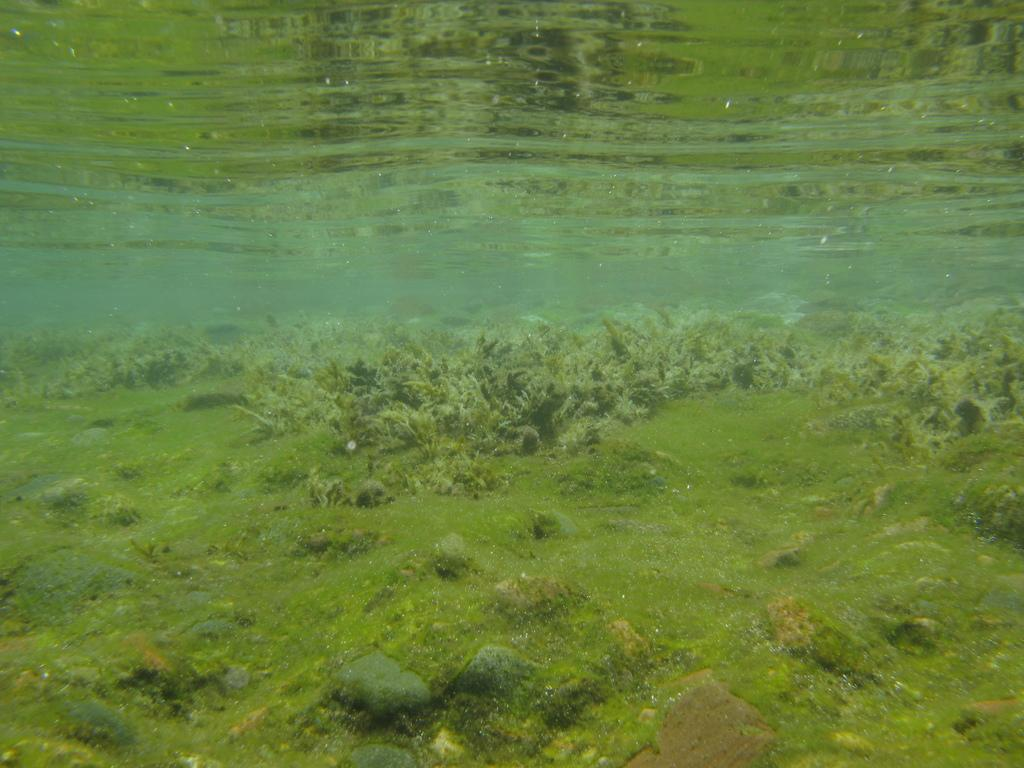What type of natural feature is present in the image? There is a lake in the image. What can be found within the lake in the image? There are many aquatic plants in the image. What effect do the aquatic plants have on the water surface in the image? The reflection of the plants can be seen on the water surface in the image. How many men are carrying baskets near the lake in the image? There are no men or baskets present in the image; it only features a lake and aquatic plants. 